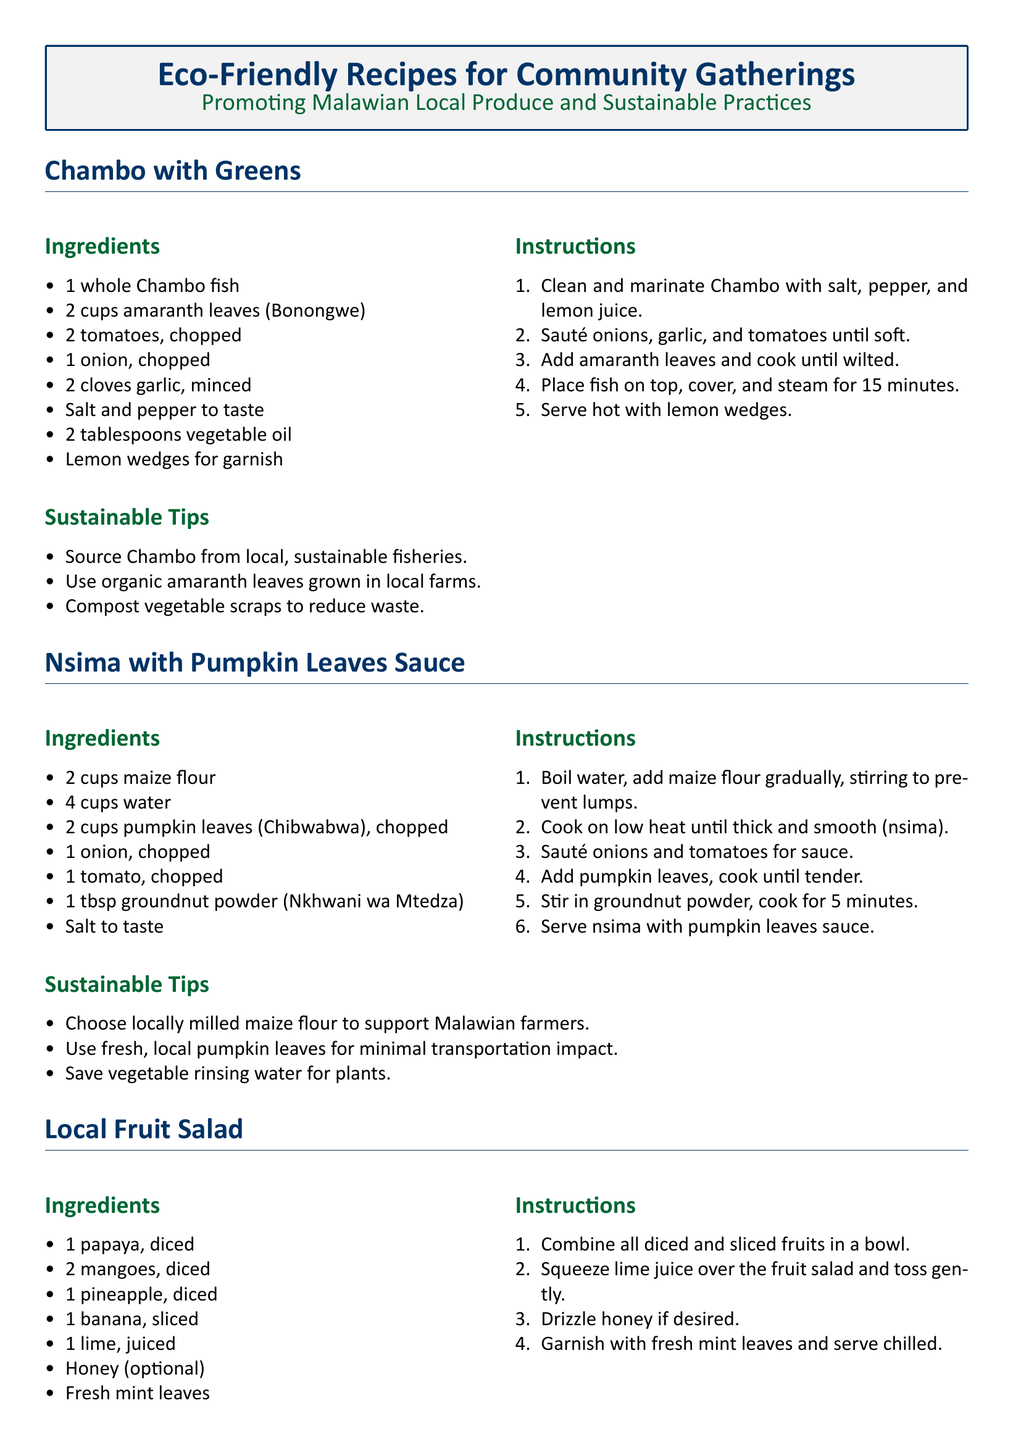What is the first recipe featured? The first recipe listed in the document is Chambo with Greens.
Answer: Chambo with Greens How many cups of amaranth leaves are required? The ingredients section specifies that 2 cups of amaranth leaves are required for the recipe.
Answer: 2 cups What main ingredient is used in the nsima recipe? The nsima recipe primarily uses maize flour as the main ingredient.
Answer: Maize flour Which ingredient is optional in the local fruit salad? Honey is specified as an optional ingredient in the local fruit salad recipe.
Answer: Honey What is the cooking method used for the Chambo fish? The Chambo fish is prepared using the steaming method as indicated in the instructions.
Answer: Steam Which section contains tips for sustainability? Sustainable Tips are included under each recipe section to promote eco-friendly practices.
Answer: Sustainable Tips What is suggested for reducing kitchen waste? Composting fruit peels and seeds is suggested as a method for reducing kitchen waste in the document.
Answer: Compost fruit peels and seeds How many types of local fruits are listed in the fruit salad recipe? There are four types of local fruits mentioned in the local fruit salad recipe.
Answer: Four What is the total cooking time for Chambo with Greens? The total cooking time for the Chambo with Greens recipe is specified as 15 minutes.
Answer: 15 minutes 